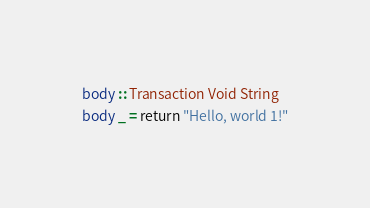Convert code to text. <code><loc_0><loc_0><loc_500><loc_500><_Haskell_>body :: Transaction Void String
body _ = return "Hello, world 1!"
</code> 